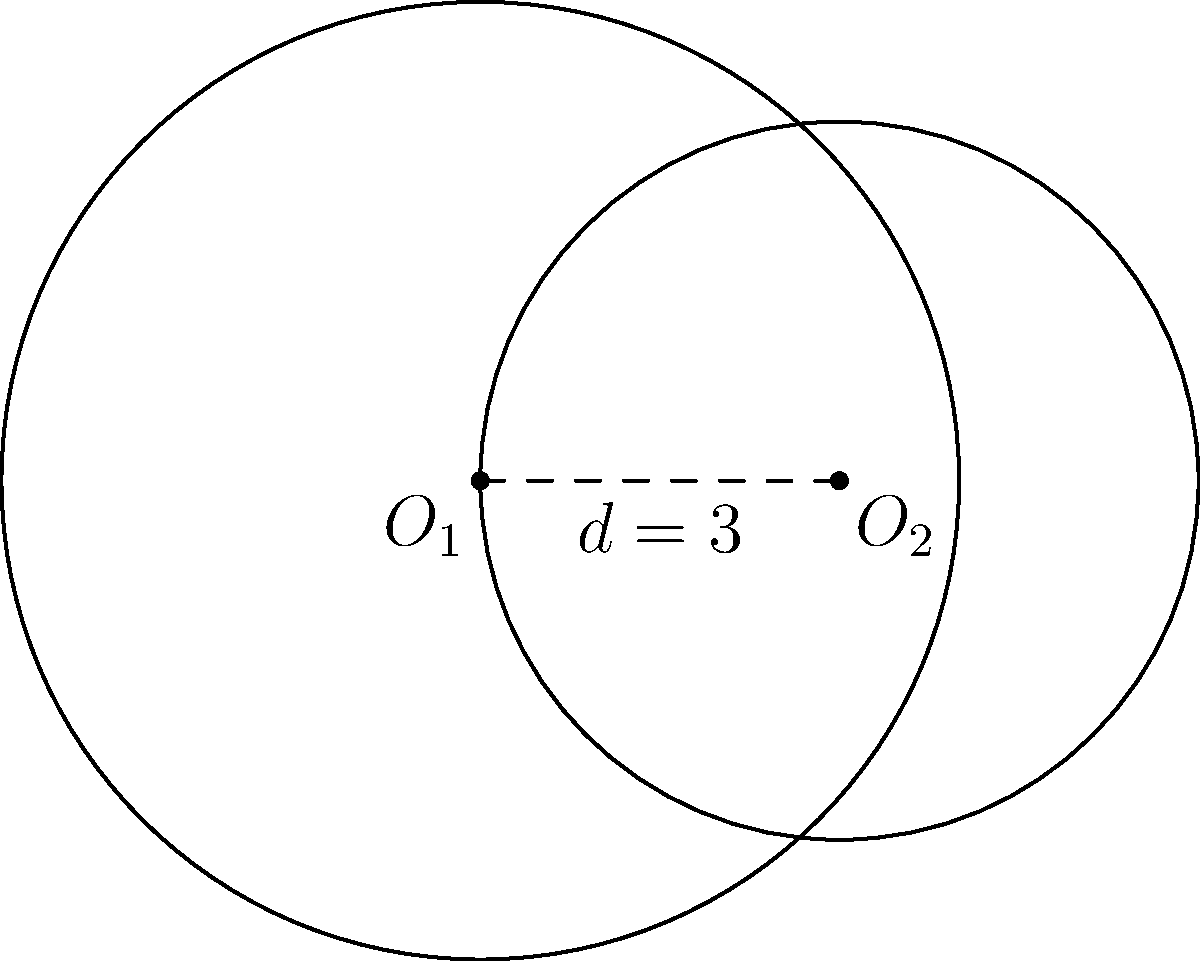As a technical writer, you're creating a document explaining the calculation of overlapping areas. Given two circles with radii $r_1 = 4$ and $r_2 = 3$, centered at $O_1$ and $O_2$ respectively, and the distance between their centers $d = 3$, calculate the area of overlap between the two circles. Round your answer to two decimal places. To calculate the area of overlap between two circles, we'll use the following steps:

1. Check if the circles overlap:
   $r_1 + r_2 > d$ (4 + 3 > 3), so they do overlap.

2. Calculate the central angles $\theta_1$ and $\theta_2$:
   $$\theta_1 = 2 \arccos\left(\frac{d^2 + r_1^2 - r_2^2}{2dr_1}\right)$$
   $$\theta_2 = 2 \arccos\left(\frac{d^2 + r_2^2 - r_1^2}{2dr_2}\right)$$

   $\theta_1 = 2 \arccos\left(\frac{3^2 + 4^2 - 3^2}{2 \cdot 3 \cdot 4}\right) = 2.7307$ radians
   $\theta_2 = 2 \arccos\left(\frac{3^2 + 3^2 - 4^2}{2 \cdot 3 \cdot 3}\right) = 3.7279$ radians

3. Calculate the areas of the circular sectors:
   $$A_1 = \frac{1}{2}r_1^2\theta_1 = \frac{1}{2} \cdot 4^2 \cdot 2.7307 = 21.8456$$
   $$A_2 = \frac{1}{2}r_2^2\theta_2 = \frac{1}{2} \cdot 3^2 \cdot 3.7279 = 16.7756$$

4. Calculate the areas of the triangles:
   $$T_1 = \frac{1}{2}r_1^2 \sin\theta_1 = \frac{1}{2} \cdot 4^2 \cdot \sin(2.7307) = 7.9719$$
   $$T_2 = \frac{1}{2}r_2^2 \sin\theta_2 = \frac{1}{2} \cdot 3^2 \cdot \sin(3.7279) = 4.4719$$

5. Calculate the area of overlap:
   $$A_{overlap} = (A_1 - T_1) + (A_2 - T_2)$$
   $$A_{overlap} = (21.8456 - 7.9719) + (16.7756 - 4.4719) = 26.1774$$

6. Round to two decimal places: 26.18
Answer: 26.18 